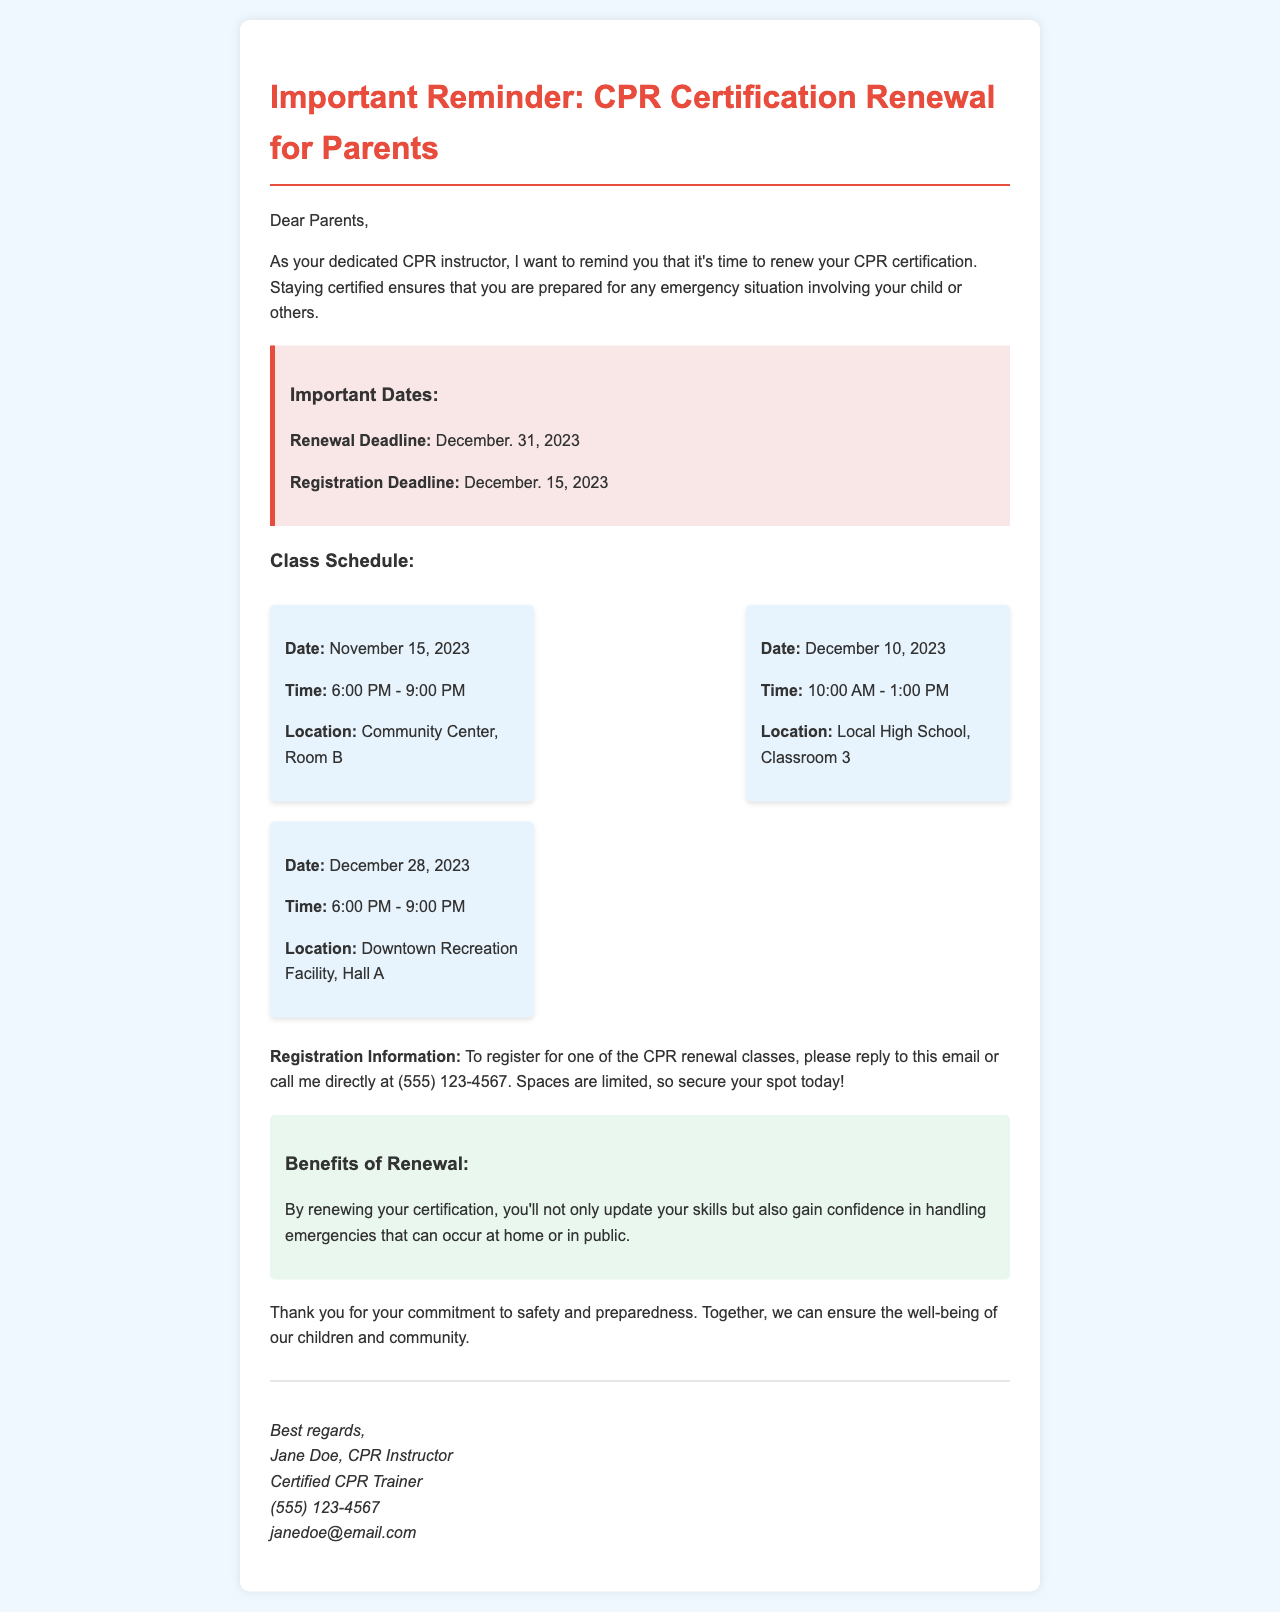What is the renewal deadline? The renewal deadline is stated as December 31, 2023, in the document.
Answer: December 31, 2023 What is the registration deadline? The registration deadline is mentioned as December 15, 2023, in the document.
Answer: December 15, 2023 When is the first CPR renewal class scheduled? The first CPR renewal class date is provided in the schedule as November 15, 2023.
Answer: November 15, 2023 How long is each class? The class duration can be inferred from the time stated, which is typically from 6:00 PM to 9:00 PM for a 3-hour class.
Answer: 3 hours What benefits are mentioned for CPR certification renewal? The document states that renewing certification updates skills and increases confidence in handling emergencies.
Answer: Update skills, increase confidence Where is the second class located? The second class's location is provided as Local High School, Classroom 3, in the document.
Answer: Local High School, Classroom 3 How can parents register for classes? The document specifies that parents can register by replying to the email or calling the instructor directly.
Answer: Reply to this email or call What is the instructor's name? The instructor's name is presented at the end of the document as Jane Doe.
Answer: Jane Doe What is the phone number listed for the instructor? The instructor's phone number is mentioned as (555) 123-4567 in the document.
Answer: (555) 123-4567 